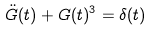<formula> <loc_0><loc_0><loc_500><loc_500>\ddot { G } ( t ) + G ( t ) ^ { 3 } = \delta ( t )</formula> 